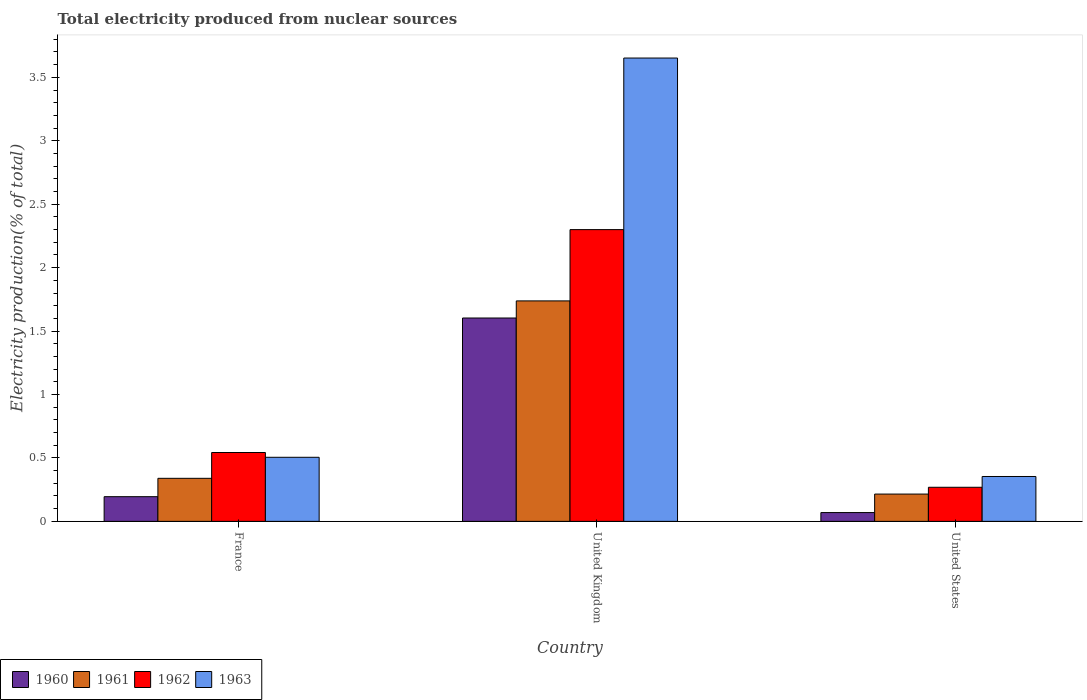What is the label of the 1st group of bars from the left?
Your answer should be very brief. France. What is the total electricity produced in 1963 in United States?
Ensure brevity in your answer.  0.35. Across all countries, what is the maximum total electricity produced in 1963?
Your answer should be compact. 3.65. Across all countries, what is the minimum total electricity produced in 1961?
Provide a short and direct response. 0.22. In which country was the total electricity produced in 1961 maximum?
Make the answer very short. United Kingdom. In which country was the total electricity produced in 1961 minimum?
Keep it short and to the point. United States. What is the total total electricity produced in 1961 in the graph?
Keep it short and to the point. 2.29. What is the difference between the total electricity produced in 1960 in United Kingdom and that in United States?
Provide a succinct answer. 1.53. What is the difference between the total electricity produced in 1960 in France and the total electricity produced in 1961 in United States?
Give a very brief answer. -0.02. What is the average total electricity produced in 1961 per country?
Keep it short and to the point. 0.76. What is the difference between the total electricity produced of/in 1962 and total electricity produced of/in 1960 in United Kingdom?
Offer a very short reply. 0.7. What is the ratio of the total electricity produced in 1962 in United Kingdom to that in United States?
Offer a terse response. 8.56. Is the total electricity produced in 1963 in France less than that in United States?
Your answer should be very brief. No. What is the difference between the highest and the second highest total electricity produced in 1961?
Ensure brevity in your answer.  -1.4. What is the difference between the highest and the lowest total electricity produced in 1963?
Keep it short and to the point. 3.3. In how many countries, is the total electricity produced in 1963 greater than the average total electricity produced in 1963 taken over all countries?
Offer a terse response. 1. Is it the case that in every country, the sum of the total electricity produced in 1961 and total electricity produced in 1960 is greater than the sum of total electricity produced in 1963 and total electricity produced in 1962?
Keep it short and to the point. Yes. What does the 2nd bar from the left in France represents?
Offer a very short reply. 1961. What does the 1st bar from the right in France represents?
Make the answer very short. 1963. Are all the bars in the graph horizontal?
Your response must be concise. No. How many countries are there in the graph?
Provide a succinct answer. 3. Does the graph contain grids?
Provide a succinct answer. No. How are the legend labels stacked?
Your answer should be compact. Horizontal. What is the title of the graph?
Your answer should be compact. Total electricity produced from nuclear sources. What is the Electricity production(% of total) in 1960 in France?
Ensure brevity in your answer.  0.19. What is the Electricity production(% of total) of 1961 in France?
Provide a succinct answer. 0.34. What is the Electricity production(% of total) of 1962 in France?
Ensure brevity in your answer.  0.54. What is the Electricity production(% of total) in 1963 in France?
Your answer should be very brief. 0.51. What is the Electricity production(% of total) of 1960 in United Kingdom?
Give a very brief answer. 1.6. What is the Electricity production(% of total) of 1961 in United Kingdom?
Offer a very short reply. 1.74. What is the Electricity production(% of total) of 1962 in United Kingdom?
Your response must be concise. 2.3. What is the Electricity production(% of total) of 1963 in United Kingdom?
Offer a terse response. 3.65. What is the Electricity production(% of total) in 1960 in United States?
Your response must be concise. 0.07. What is the Electricity production(% of total) in 1961 in United States?
Your response must be concise. 0.22. What is the Electricity production(% of total) of 1962 in United States?
Offer a very short reply. 0.27. What is the Electricity production(% of total) of 1963 in United States?
Provide a short and direct response. 0.35. Across all countries, what is the maximum Electricity production(% of total) of 1960?
Your answer should be very brief. 1.6. Across all countries, what is the maximum Electricity production(% of total) in 1961?
Provide a succinct answer. 1.74. Across all countries, what is the maximum Electricity production(% of total) of 1962?
Ensure brevity in your answer.  2.3. Across all countries, what is the maximum Electricity production(% of total) of 1963?
Your response must be concise. 3.65. Across all countries, what is the minimum Electricity production(% of total) in 1960?
Keep it short and to the point. 0.07. Across all countries, what is the minimum Electricity production(% of total) of 1961?
Your response must be concise. 0.22. Across all countries, what is the minimum Electricity production(% of total) in 1962?
Your answer should be very brief. 0.27. Across all countries, what is the minimum Electricity production(% of total) of 1963?
Provide a short and direct response. 0.35. What is the total Electricity production(% of total) of 1960 in the graph?
Your answer should be compact. 1.87. What is the total Electricity production(% of total) of 1961 in the graph?
Your answer should be compact. 2.29. What is the total Electricity production(% of total) of 1962 in the graph?
Your answer should be very brief. 3.11. What is the total Electricity production(% of total) in 1963 in the graph?
Offer a very short reply. 4.51. What is the difference between the Electricity production(% of total) of 1960 in France and that in United Kingdom?
Ensure brevity in your answer.  -1.41. What is the difference between the Electricity production(% of total) in 1961 in France and that in United Kingdom?
Keep it short and to the point. -1.4. What is the difference between the Electricity production(% of total) of 1962 in France and that in United Kingdom?
Make the answer very short. -1.76. What is the difference between the Electricity production(% of total) of 1963 in France and that in United Kingdom?
Provide a short and direct response. -3.15. What is the difference between the Electricity production(% of total) in 1960 in France and that in United States?
Ensure brevity in your answer.  0.13. What is the difference between the Electricity production(% of total) in 1961 in France and that in United States?
Give a very brief answer. 0.12. What is the difference between the Electricity production(% of total) in 1962 in France and that in United States?
Your response must be concise. 0.27. What is the difference between the Electricity production(% of total) in 1963 in France and that in United States?
Offer a terse response. 0.15. What is the difference between the Electricity production(% of total) in 1960 in United Kingdom and that in United States?
Your answer should be very brief. 1.53. What is the difference between the Electricity production(% of total) in 1961 in United Kingdom and that in United States?
Your answer should be compact. 1.52. What is the difference between the Electricity production(% of total) in 1962 in United Kingdom and that in United States?
Provide a succinct answer. 2.03. What is the difference between the Electricity production(% of total) of 1963 in United Kingdom and that in United States?
Provide a short and direct response. 3.3. What is the difference between the Electricity production(% of total) in 1960 in France and the Electricity production(% of total) in 1961 in United Kingdom?
Keep it short and to the point. -1.54. What is the difference between the Electricity production(% of total) in 1960 in France and the Electricity production(% of total) in 1962 in United Kingdom?
Provide a short and direct response. -2.11. What is the difference between the Electricity production(% of total) of 1960 in France and the Electricity production(% of total) of 1963 in United Kingdom?
Offer a terse response. -3.46. What is the difference between the Electricity production(% of total) in 1961 in France and the Electricity production(% of total) in 1962 in United Kingdom?
Your response must be concise. -1.96. What is the difference between the Electricity production(% of total) in 1961 in France and the Electricity production(% of total) in 1963 in United Kingdom?
Offer a terse response. -3.31. What is the difference between the Electricity production(% of total) in 1962 in France and the Electricity production(% of total) in 1963 in United Kingdom?
Your answer should be compact. -3.11. What is the difference between the Electricity production(% of total) in 1960 in France and the Electricity production(% of total) in 1961 in United States?
Your response must be concise. -0.02. What is the difference between the Electricity production(% of total) of 1960 in France and the Electricity production(% of total) of 1962 in United States?
Your response must be concise. -0.07. What is the difference between the Electricity production(% of total) of 1960 in France and the Electricity production(% of total) of 1963 in United States?
Provide a short and direct response. -0.16. What is the difference between the Electricity production(% of total) of 1961 in France and the Electricity production(% of total) of 1962 in United States?
Your answer should be very brief. 0.07. What is the difference between the Electricity production(% of total) in 1961 in France and the Electricity production(% of total) in 1963 in United States?
Ensure brevity in your answer.  -0.01. What is the difference between the Electricity production(% of total) of 1962 in France and the Electricity production(% of total) of 1963 in United States?
Your answer should be very brief. 0.19. What is the difference between the Electricity production(% of total) of 1960 in United Kingdom and the Electricity production(% of total) of 1961 in United States?
Your answer should be compact. 1.39. What is the difference between the Electricity production(% of total) in 1960 in United Kingdom and the Electricity production(% of total) in 1962 in United States?
Offer a terse response. 1.33. What is the difference between the Electricity production(% of total) of 1960 in United Kingdom and the Electricity production(% of total) of 1963 in United States?
Provide a short and direct response. 1.25. What is the difference between the Electricity production(% of total) in 1961 in United Kingdom and the Electricity production(% of total) in 1962 in United States?
Your response must be concise. 1.47. What is the difference between the Electricity production(% of total) of 1961 in United Kingdom and the Electricity production(% of total) of 1963 in United States?
Ensure brevity in your answer.  1.38. What is the difference between the Electricity production(% of total) of 1962 in United Kingdom and the Electricity production(% of total) of 1963 in United States?
Your answer should be very brief. 1.95. What is the average Electricity production(% of total) of 1960 per country?
Provide a succinct answer. 0.62. What is the average Electricity production(% of total) of 1961 per country?
Offer a very short reply. 0.76. What is the average Electricity production(% of total) in 1962 per country?
Give a very brief answer. 1.04. What is the average Electricity production(% of total) of 1963 per country?
Offer a terse response. 1.5. What is the difference between the Electricity production(% of total) of 1960 and Electricity production(% of total) of 1961 in France?
Provide a short and direct response. -0.14. What is the difference between the Electricity production(% of total) of 1960 and Electricity production(% of total) of 1962 in France?
Provide a succinct answer. -0.35. What is the difference between the Electricity production(% of total) in 1960 and Electricity production(% of total) in 1963 in France?
Your answer should be very brief. -0.31. What is the difference between the Electricity production(% of total) of 1961 and Electricity production(% of total) of 1962 in France?
Provide a short and direct response. -0.2. What is the difference between the Electricity production(% of total) of 1961 and Electricity production(% of total) of 1963 in France?
Your answer should be very brief. -0.17. What is the difference between the Electricity production(% of total) of 1962 and Electricity production(% of total) of 1963 in France?
Your answer should be compact. 0.04. What is the difference between the Electricity production(% of total) in 1960 and Electricity production(% of total) in 1961 in United Kingdom?
Give a very brief answer. -0.13. What is the difference between the Electricity production(% of total) of 1960 and Electricity production(% of total) of 1962 in United Kingdom?
Offer a terse response. -0.7. What is the difference between the Electricity production(% of total) of 1960 and Electricity production(% of total) of 1963 in United Kingdom?
Keep it short and to the point. -2.05. What is the difference between the Electricity production(% of total) in 1961 and Electricity production(% of total) in 1962 in United Kingdom?
Provide a short and direct response. -0.56. What is the difference between the Electricity production(% of total) of 1961 and Electricity production(% of total) of 1963 in United Kingdom?
Your answer should be compact. -1.91. What is the difference between the Electricity production(% of total) of 1962 and Electricity production(% of total) of 1963 in United Kingdom?
Make the answer very short. -1.35. What is the difference between the Electricity production(% of total) of 1960 and Electricity production(% of total) of 1961 in United States?
Make the answer very short. -0.15. What is the difference between the Electricity production(% of total) in 1960 and Electricity production(% of total) in 1962 in United States?
Offer a terse response. -0.2. What is the difference between the Electricity production(% of total) in 1960 and Electricity production(% of total) in 1963 in United States?
Provide a succinct answer. -0.28. What is the difference between the Electricity production(% of total) in 1961 and Electricity production(% of total) in 1962 in United States?
Your answer should be very brief. -0.05. What is the difference between the Electricity production(% of total) of 1961 and Electricity production(% of total) of 1963 in United States?
Ensure brevity in your answer.  -0.14. What is the difference between the Electricity production(% of total) in 1962 and Electricity production(% of total) in 1963 in United States?
Offer a very short reply. -0.09. What is the ratio of the Electricity production(% of total) of 1960 in France to that in United Kingdom?
Provide a short and direct response. 0.12. What is the ratio of the Electricity production(% of total) of 1961 in France to that in United Kingdom?
Give a very brief answer. 0.2. What is the ratio of the Electricity production(% of total) in 1962 in France to that in United Kingdom?
Your answer should be very brief. 0.24. What is the ratio of the Electricity production(% of total) in 1963 in France to that in United Kingdom?
Provide a short and direct response. 0.14. What is the ratio of the Electricity production(% of total) of 1960 in France to that in United States?
Your response must be concise. 2.81. What is the ratio of the Electricity production(% of total) in 1961 in France to that in United States?
Your response must be concise. 1.58. What is the ratio of the Electricity production(% of total) of 1962 in France to that in United States?
Your answer should be very brief. 2.02. What is the ratio of the Electricity production(% of total) of 1963 in France to that in United States?
Keep it short and to the point. 1.43. What is the ratio of the Electricity production(% of total) in 1960 in United Kingdom to that in United States?
Make the answer very short. 23.14. What is the ratio of the Electricity production(% of total) of 1961 in United Kingdom to that in United States?
Give a very brief answer. 8.08. What is the ratio of the Electricity production(% of total) in 1962 in United Kingdom to that in United States?
Give a very brief answer. 8.56. What is the ratio of the Electricity production(% of total) of 1963 in United Kingdom to that in United States?
Provide a succinct answer. 10.32. What is the difference between the highest and the second highest Electricity production(% of total) in 1960?
Your answer should be very brief. 1.41. What is the difference between the highest and the second highest Electricity production(% of total) of 1961?
Your answer should be compact. 1.4. What is the difference between the highest and the second highest Electricity production(% of total) in 1962?
Your answer should be compact. 1.76. What is the difference between the highest and the second highest Electricity production(% of total) of 1963?
Your response must be concise. 3.15. What is the difference between the highest and the lowest Electricity production(% of total) in 1960?
Your answer should be compact. 1.53. What is the difference between the highest and the lowest Electricity production(% of total) in 1961?
Provide a succinct answer. 1.52. What is the difference between the highest and the lowest Electricity production(% of total) in 1962?
Your response must be concise. 2.03. What is the difference between the highest and the lowest Electricity production(% of total) in 1963?
Your answer should be very brief. 3.3. 